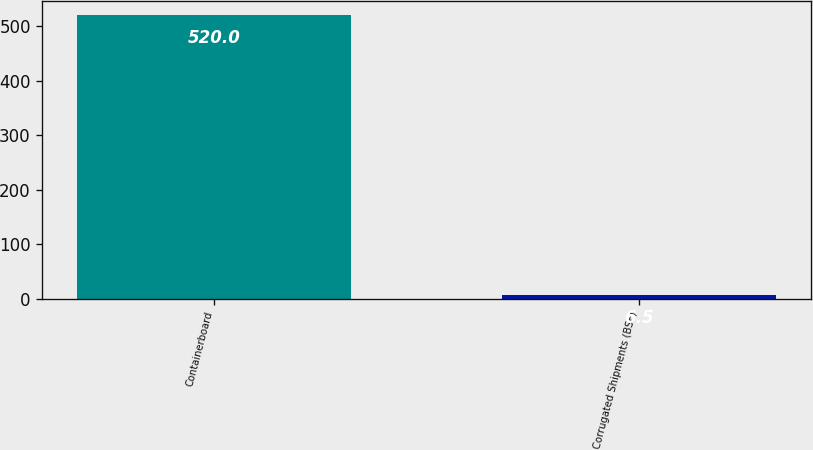<chart> <loc_0><loc_0><loc_500><loc_500><bar_chart><fcel>Containerboard<fcel>Corrugated Shipments (BSF)<nl><fcel>520<fcel>6.5<nl></chart> 